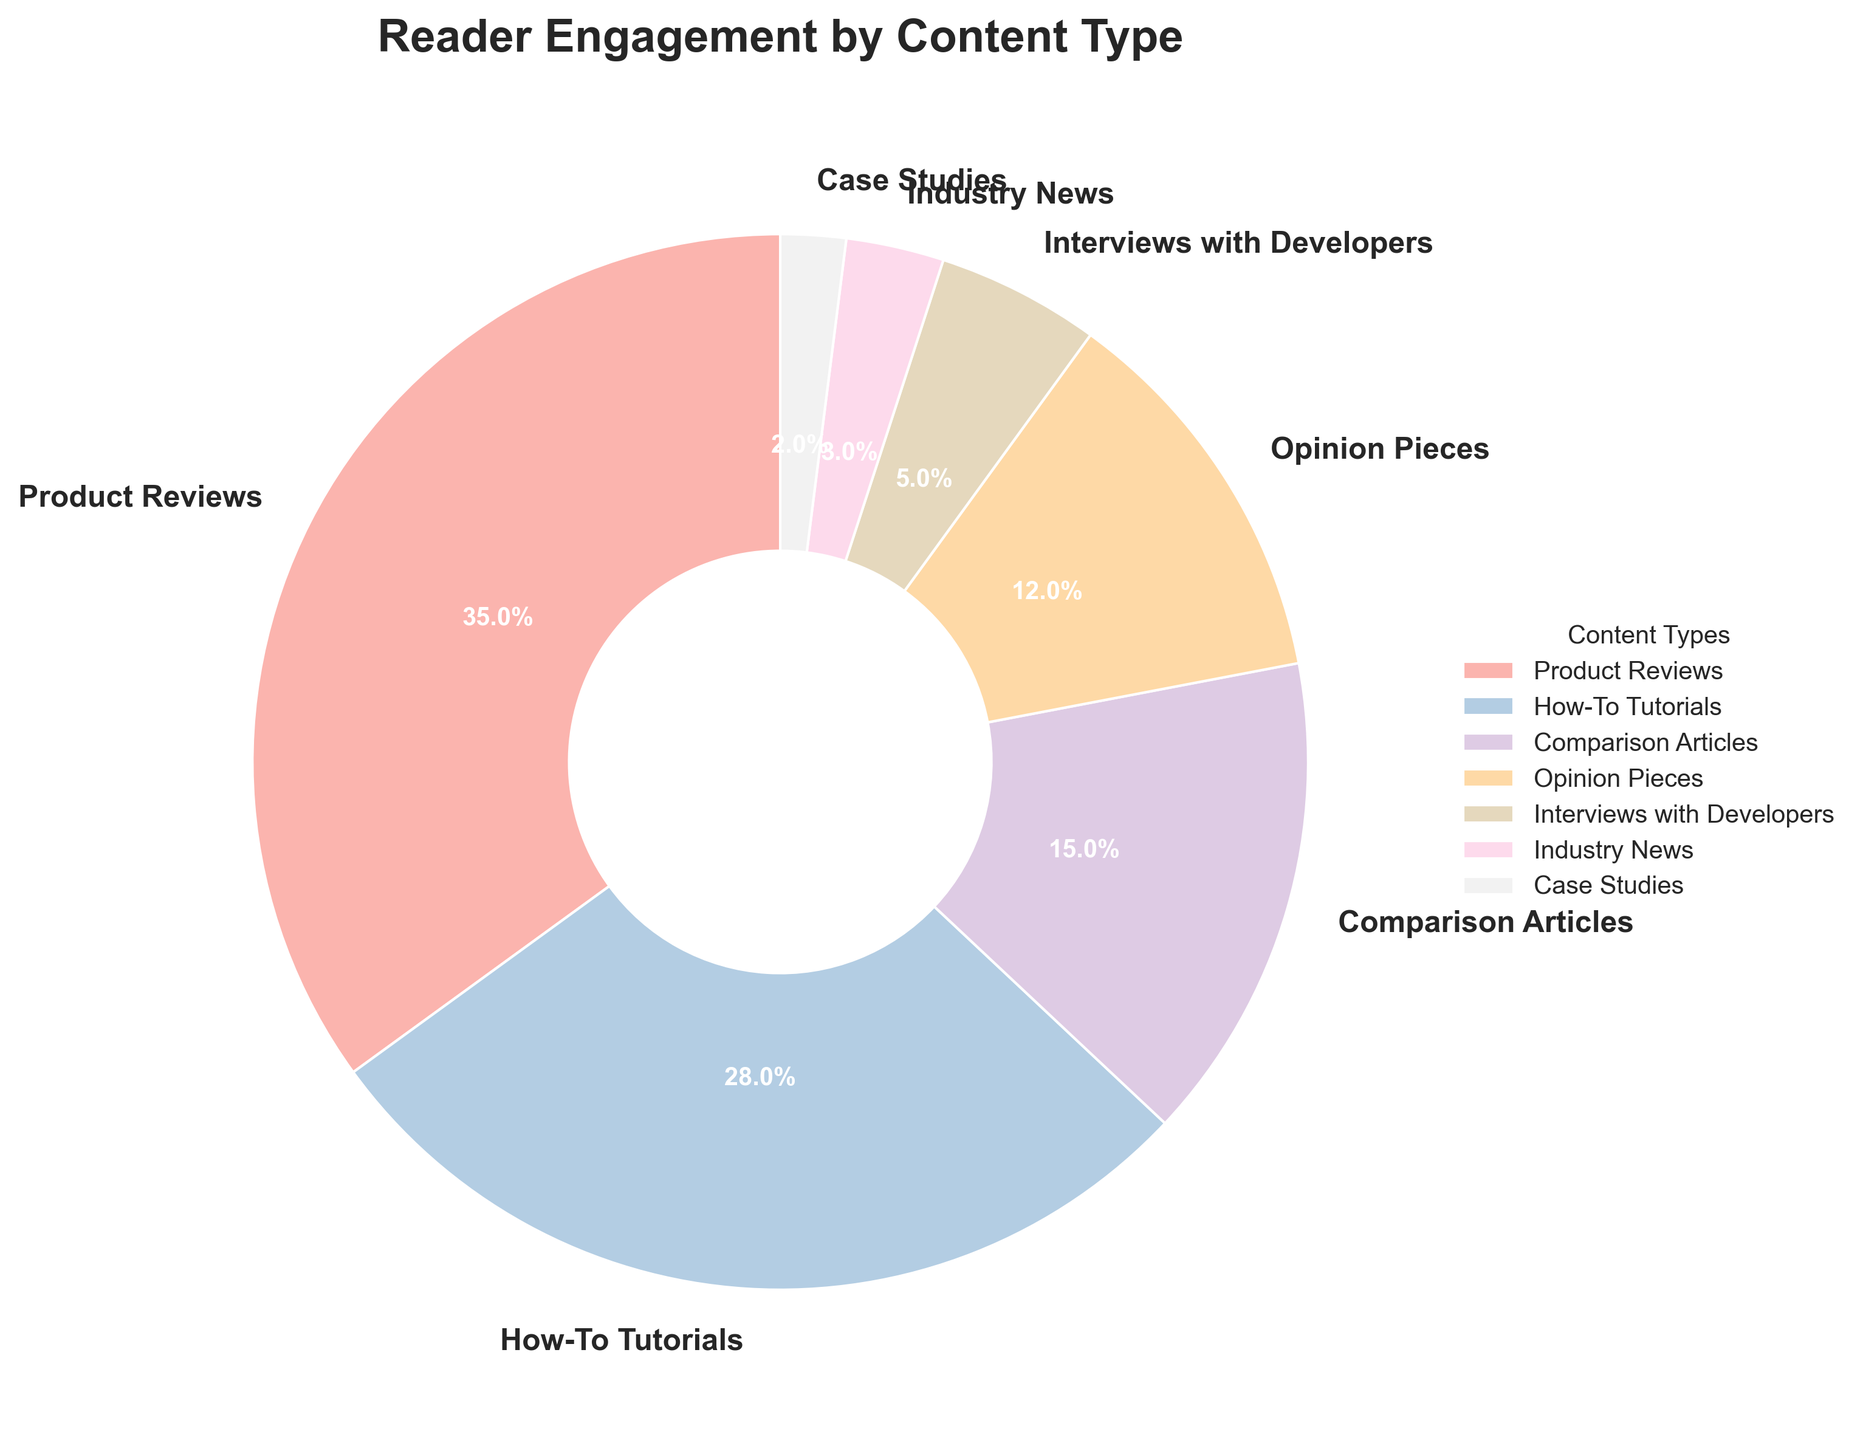What's the most engaging content type? The largest wedge in the pie chart represents Product Reviews with 35% engagement, which is the highest.
Answer: Product Reviews Which content type has the least reader engagement? The smallest wedge in the pie chart is for Case Studies with 2% engagement.
Answer: Case Studies What is the combined engagement percentage of How-To Tutorials and Comparison Articles? Add the engagement percentages of How-To Tutorials (28%) and Comparison Articles (15%). So, 28% + 15% = 43%.
Answer: 43% Compare the engagement between Opinion Pieces and Interviews with Developers. Which one has a higher engagement? Opinion Pieces have an engagement percentage of 12%, whereas Interviews with Developers have 5%. Therefore, Opinion Pieces have a higher engagement.
Answer: Opinion Pieces How much more engagement do Product Reviews have compared to Industry News? Subtract the engagement percentage of Industry News (3%) from Product Reviews (35%). So, 35% - 3% = 32%.
Answer: 32% What percentage of reader engagement is shared between Opinion Pieces, Interviews with Developers, Industry News, and Case Studies combined? Add the engagement percentages of Opinion Pieces (12%), Interviews with Developers (5%), Industry News (3%), and Case Studies (2%). So, 12% + 5% + 3% + 2% = 22%.
Answer: 22% Which content type has a slightly higher engagement than Comparison Articles? The next highest wedge is How-To Tutorials with 28%, while Comparison Articles have 15%, which is slightly lower.
Answer: How-To Tutorials What can you infer about the visual size of the wedge representing the least engaging content type? The wedge representing Case Studies is the smallest and it takes up only 2% of the pie chart, making it look significantly smaller than the others.
Answer: It is very small 